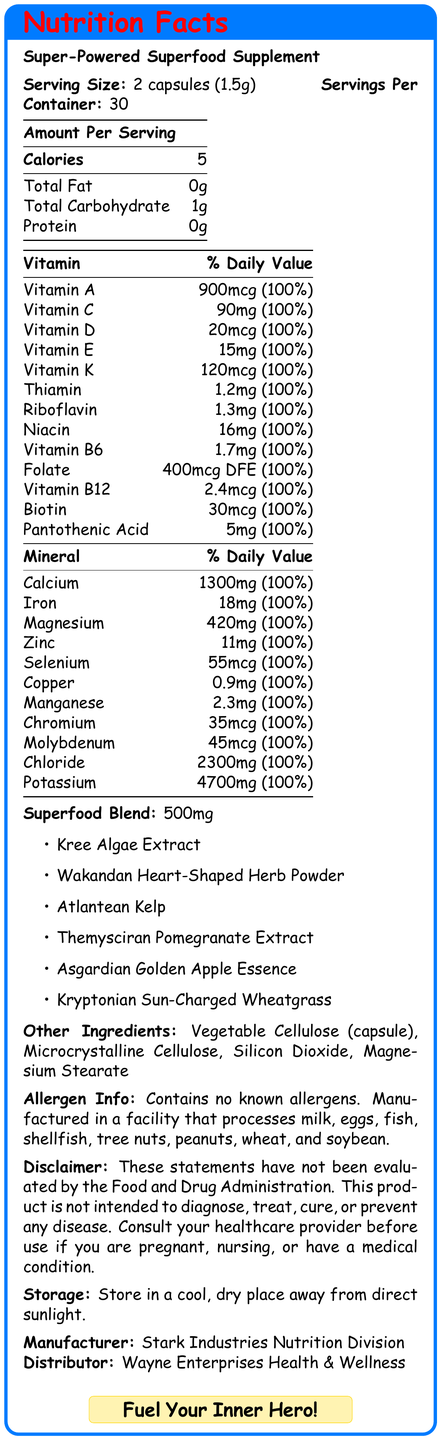what is the serving size of the Super-Powered Superfood Supplement? The document lists the serving size as "2 capsules (1.5g)".
Answer: 2 capsules (1.5g) how many servings are in one container of the supplement? The document specifies "Servings Per Container: 30".
Answer: 30 how many calories are in one serving of the supplement? The document states that each serving contains 5 calories.
Answer: 5 who is the manufacturer of the Super-Powered Superfood Supplement? The manufacturer is mentioned in the document as "Stark Industries Nutrition Division".
Answer: Stark Industries Nutrition Division list three superfood ingredients used in this supplement. These ingredients are listed under the "Superfood Blend" section.
Answer: Kree Algae Extract, Wakandan Heart-Shaped Herb Powder, Atlantean Kelp Which vitamin provides 90mg per serving, meeting 100% of the daily value? A. Vitamin A B. Vitamin C C. Vitamin D D. Vitamin B12 The document lists "Vitamin C: 90mg (100% DV)".
Answer: B Which company distributes the Super-Powered Superfood Supplement? i. Stark Industries Nutrition Division ii. Wayne Enterprises Health & Wellness iii. Daily Planet Supplements The document lists "Distributor: Wayne Enterprises Health & Wellness".
Answer: ii Is the supplement intended to diagnose, treat, cure, or prevent any disease? The document includes a disclaimer stating that the statements have not been evaluated by the FDA and the product is not intended for diagnosing, treating, curing, or preventing any disease.
Answer: No does the supplement contain any known allergens? The document mentions that the supplement contains no known allergens.
Answer: No describe the main elements of the Nutrition Facts Label for the Super-Powered Superfood Supplement. The document comprehensively outlines the supplement's nutritional information, ingredient list, and additional details while being styled in a comic-book inspired graphic format, making it visually engaging and informative.
Answer: The Nutrition Facts Label for the Super-Powered Superfood Supplement includes details about serving size, servings per container, calories, amounts of various vitamins and minerals (each providing 100% of the daily value), a list of superfood ingredients, other ingredients, allergen information, a disclaimer, storage instructions, manufacturer and distributor information, and a marketing tagline. The document also features comic-style elements like bold colors, superhero silhouettes, speech bubbles, and dynamic action lines. what is the weight of the potassium provided in one serving? The document provides the weight of potassium as 4700mg but doesn't specify if this is per serving or for the entire container.
Answer: Cannot be determined how many milligrams of magnesium does one serving contain? The "Mineral" section of the document lists magnesium content as "420mg (100% DV)".
Answer: 420mg what is the daily percentage value for vitamin A in one serving? Under the "Vitamin" section, the daily value for vitamin A is given as 100%.
Answer: 100% which superhero-inspired superfood ingredient might be associated with increased strength? A. Kryptonian Sun-Charged Wheatgrass B. Atlantean Kelp C. Themysciran Pomegranate Extract D. Asgardian Golden Apple Essence Kryptonian Sun-Charged Wheatgrass is inspired by Superman's association with the sun, which gives him strength.
Answer: A what is the recommended storage condition for the supplement? The document includes storage instructions stating to keep the supplement in a cool, dry place away from direct sunlight.
Answer: Store in a cool, dry place away from direct sunlight 